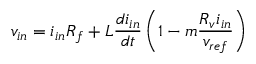Convert formula to latex. <formula><loc_0><loc_0><loc_500><loc_500>v _ { i n } = i _ { i n } R _ { f } + L \frac { d i _ { i n } } { d t } \left ( 1 - m \frac { R _ { v } i _ { i n } } { v _ { r e f } } \right )</formula> 